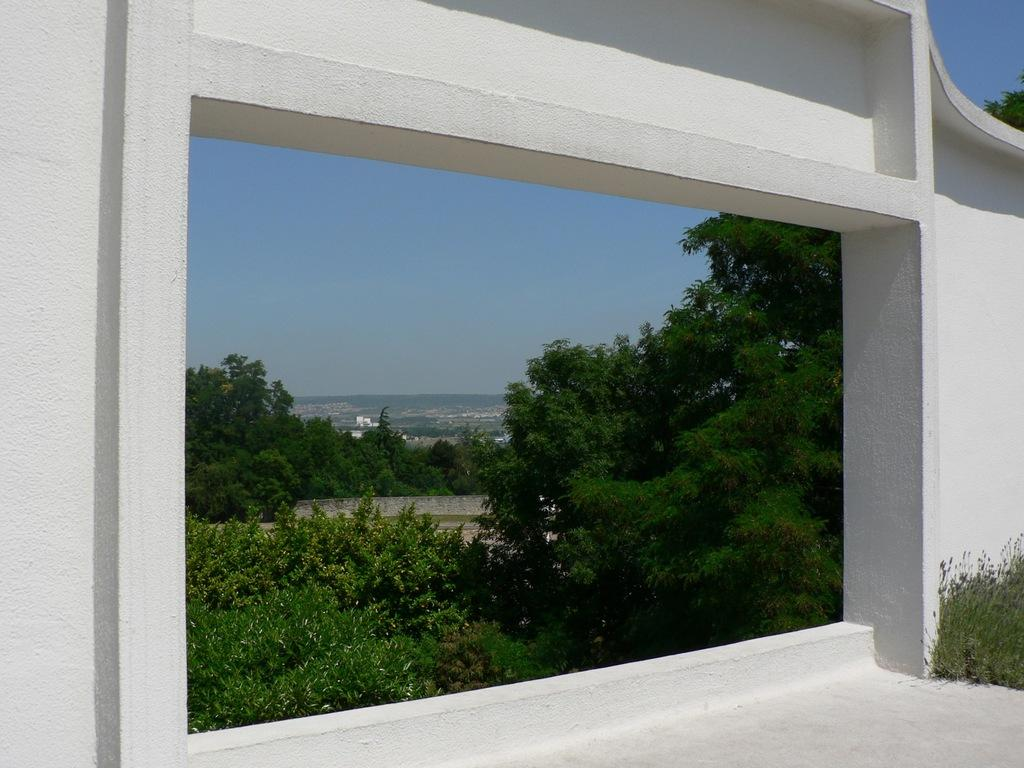What is the main feature in the foreground of the image? There is a gap in the wall in the foreground of the image. What can be seen through the gap? The city and the sky are visible through the gap. How many elements can be seen through the gap? Two elements, the city and the sky, can be seen through the gap. What type of tub is visible in the image? There is no tub present in the image. Can you see a railway through the gap in the wall? The image does not show a railway; it only shows the city and the sky through the gap. 